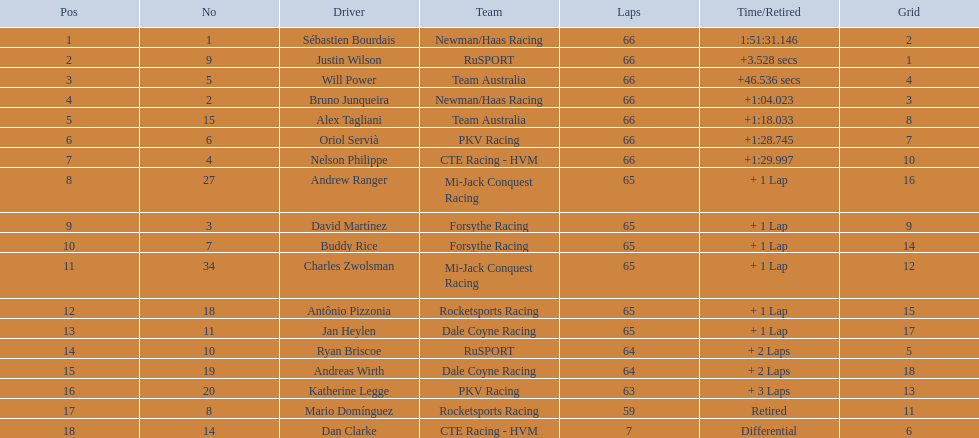How many points did first place receive? 34. How many did last place receive? 3. Who was the recipient of these last place points? Dan Clarke. 